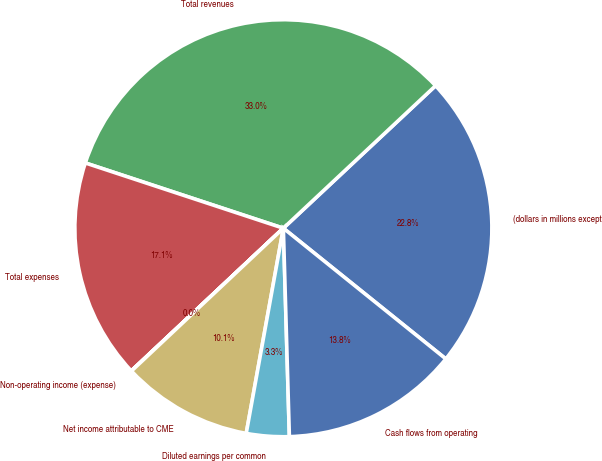Convert chart. <chart><loc_0><loc_0><loc_500><loc_500><pie_chart><fcel>(dollars in millions except<fcel>Total revenues<fcel>Total expenses<fcel>Non-operating income (expense)<fcel>Net income attributable to CME<fcel>Diluted earnings per common<fcel>Cash flows from operating<nl><fcel>22.76%<fcel>32.96%<fcel>17.06%<fcel>0.02%<fcel>10.14%<fcel>3.31%<fcel>13.76%<nl></chart> 